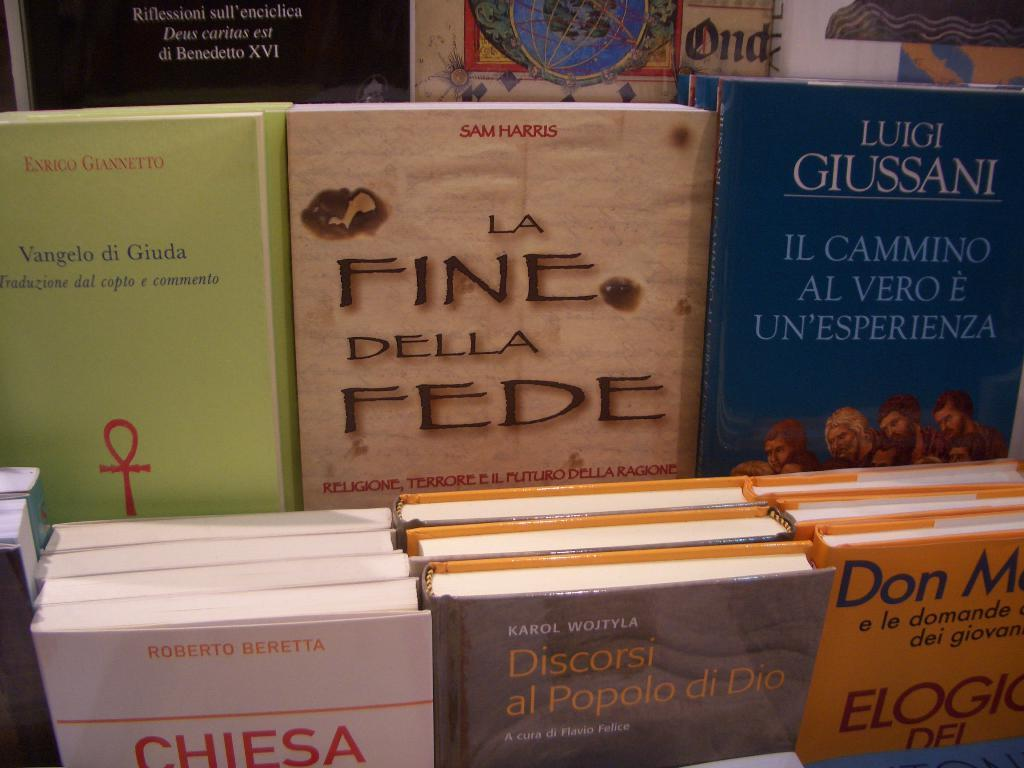Provide a one-sentence caption for the provided image. Various books with colorful colors are standing in a displace, the one in the center is La Fine Della Fede. 